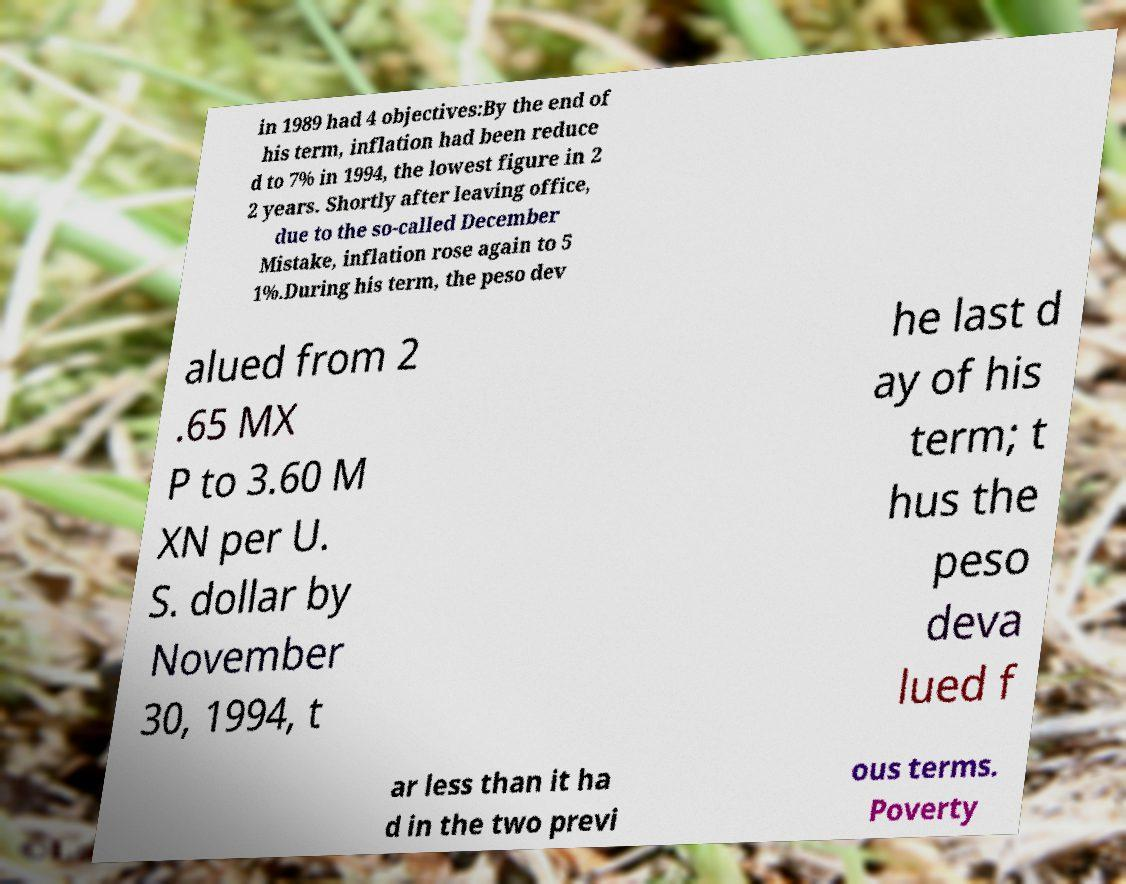Can you accurately transcribe the text from the provided image for me? in 1989 had 4 objectives:By the end of his term, inflation had been reduce d to 7% in 1994, the lowest figure in 2 2 years. Shortly after leaving office, due to the so-called December Mistake, inflation rose again to 5 1%.During his term, the peso dev alued from 2 .65 MX P to 3.60 M XN per U. S. dollar by November 30, 1994, t he last d ay of his term; t hus the peso deva lued f ar less than it ha d in the two previ ous terms. Poverty 